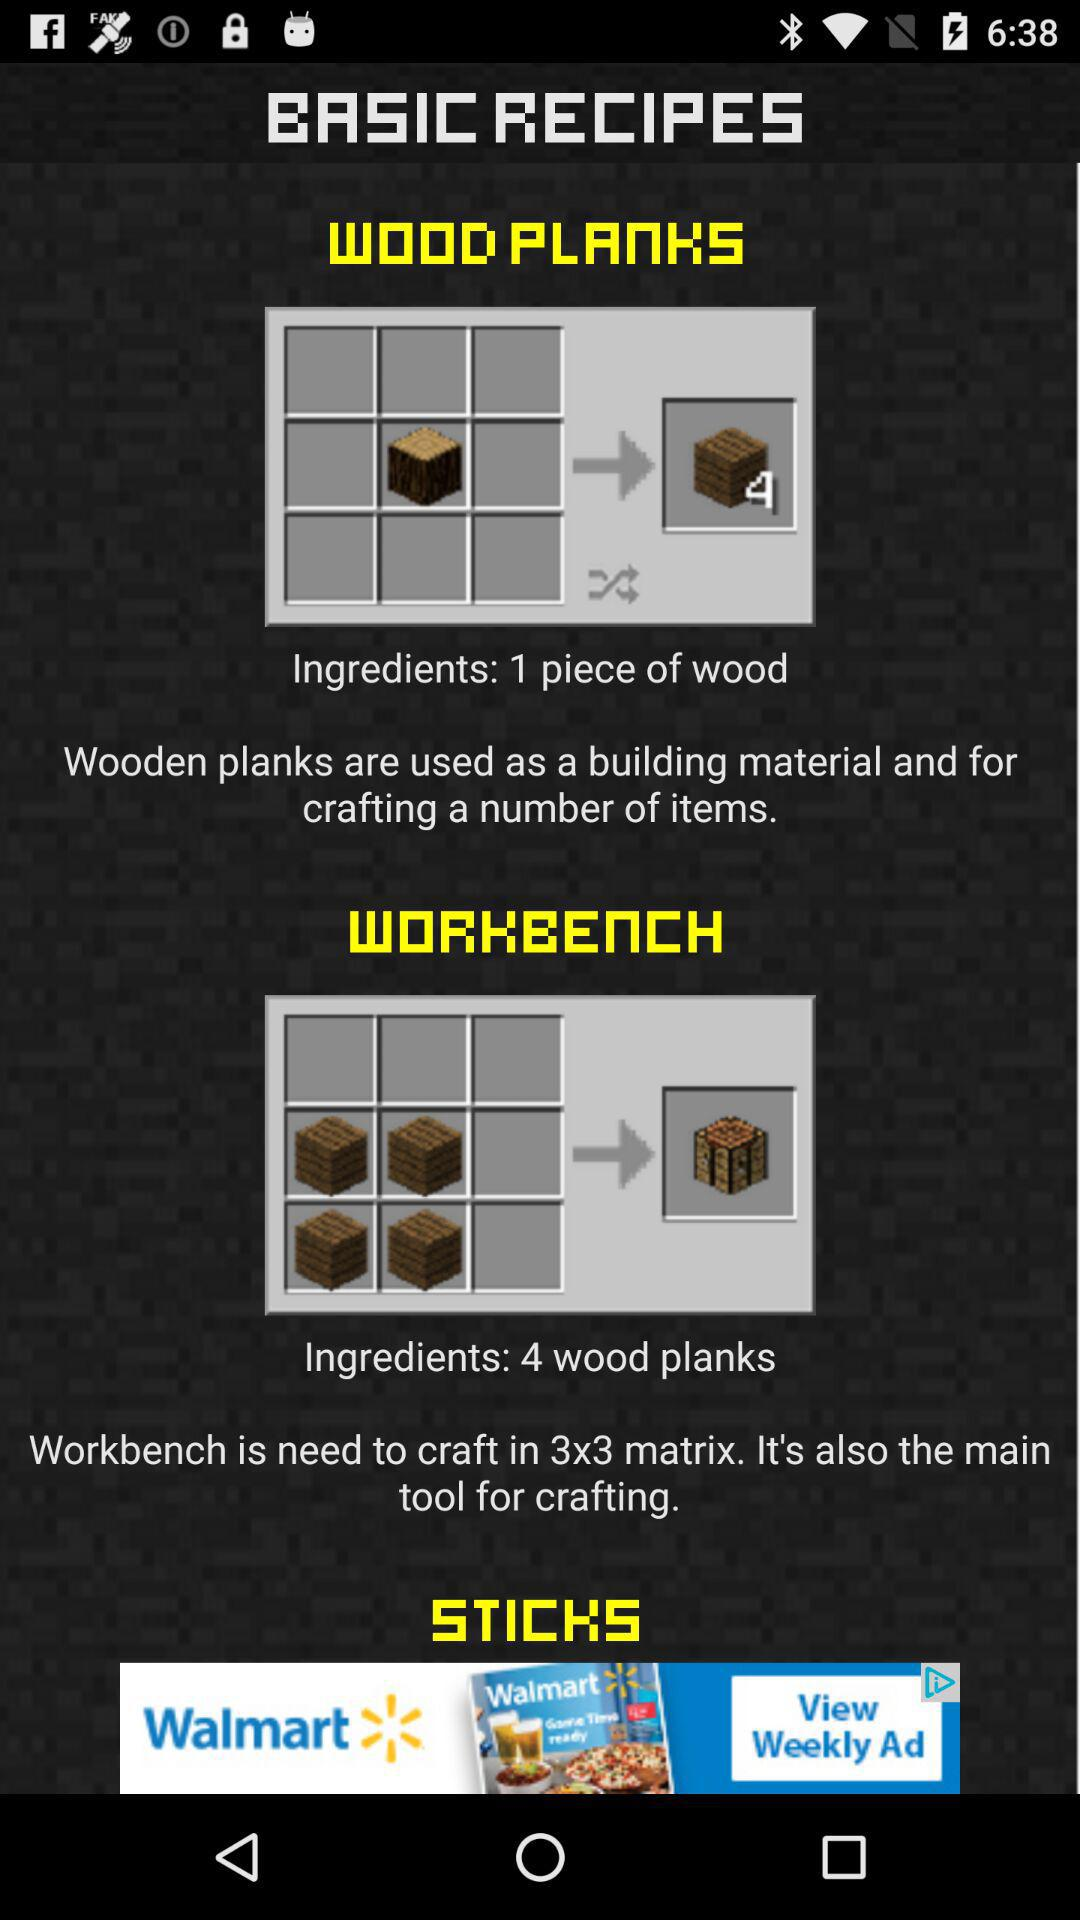What are the ingredients for the workbench? The ingredients are four wood planks. 